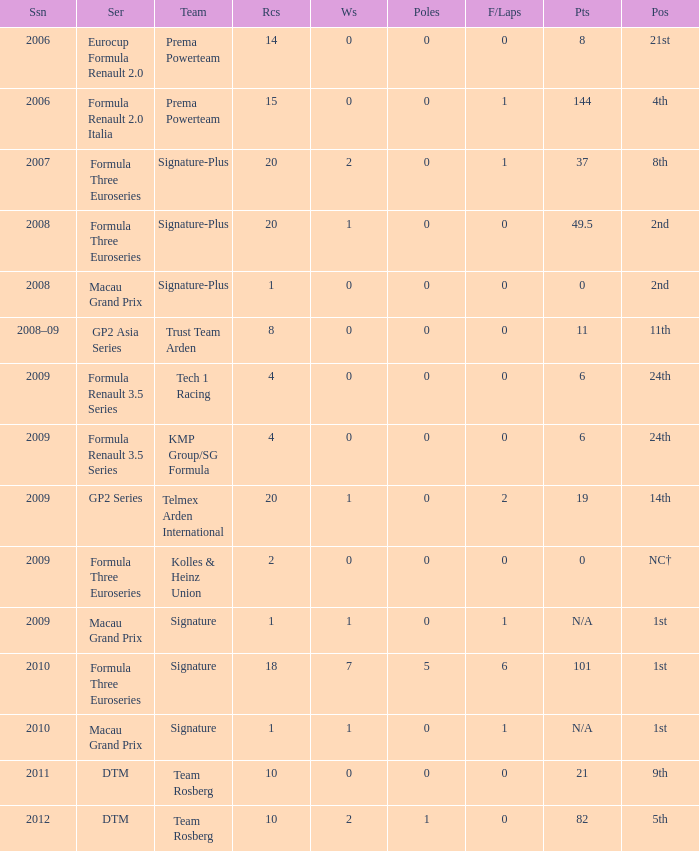How many poles are there in the 2009 season with 2 races and more than 0 F/Laps? 0.0. 